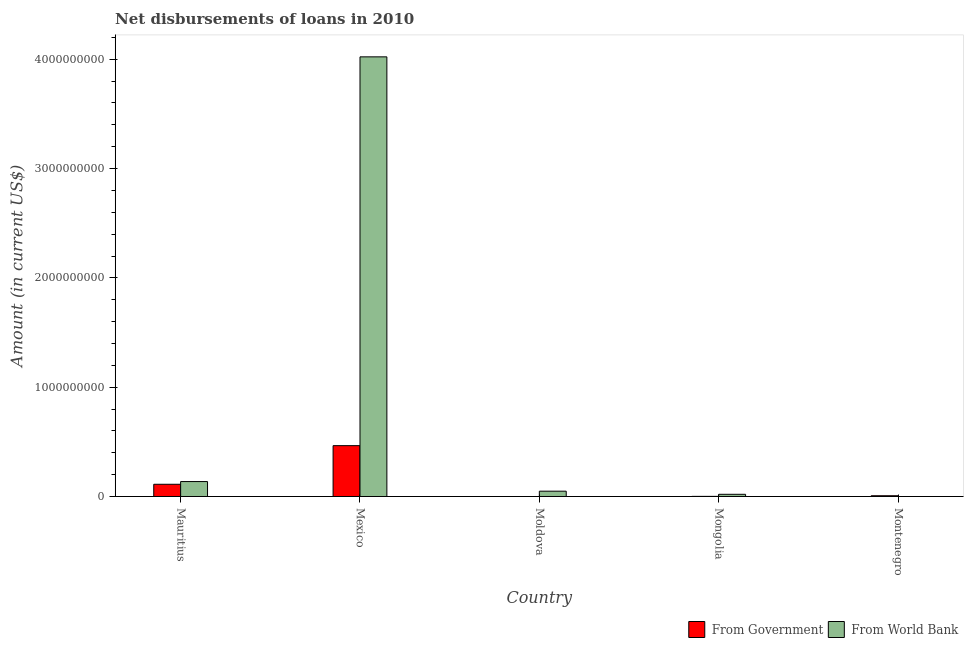Are the number of bars per tick equal to the number of legend labels?
Your answer should be compact. No. Are the number of bars on each tick of the X-axis equal?
Provide a succinct answer. No. How many bars are there on the 4th tick from the left?
Give a very brief answer. 2. How many bars are there on the 4th tick from the right?
Give a very brief answer. 2. What is the label of the 5th group of bars from the left?
Make the answer very short. Montenegro. In how many cases, is the number of bars for a given country not equal to the number of legend labels?
Your answer should be very brief. 2. What is the net disbursements of loan from world bank in Moldova?
Your answer should be compact. 4.88e+07. Across all countries, what is the maximum net disbursements of loan from world bank?
Your answer should be compact. 4.02e+09. Across all countries, what is the minimum net disbursements of loan from world bank?
Your response must be concise. 0. What is the total net disbursements of loan from world bank in the graph?
Your response must be concise. 4.23e+09. What is the difference between the net disbursements of loan from world bank in Mauritius and that in Moldova?
Provide a succinct answer. 8.80e+07. What is the average net disbursements of loan from world bank per country?
Make the answer very short. 8.46e+08. What is the difference between the net disbursements of loan from government and net disbursements of loan from world bank in Mongolia?
Offer a terse response. -1.88e+07. In how many countries, is the net disbursements of loan from government greater than 3800000000 US$?
Make the answer very short. 0. What is the ratio of the net disbursements of loan from government in Mongolia to that in Montenegro?
Provide a short and direct response. 0.19. Is the net disbursements of loan from government in Mauritius less than that in Montenegro?
Keep it short and to the point. No. What is the difference between the highest and the second highest net disbursements of loan from government?
Provide a succinct answer. 3.53e+08. What is the difference between the highest and the lowest net disbursements of loan from world bank?
Ensure brevity in your answer.  4.02e+09. How many countries are there in the graph?
Offer a terse response. 5. What is the difference between two consecutive major ticks on the Y-axis?
Make the answer very short. 1.00e+09. Does the graph contain grids?
Your response must be concise. No. Where does the legend appear in the graph?
Keep it short and to the point. Bottom right. How many legend labels are there?
Give a very brief answer. 2. What is the title of the graph?
Make the answer very short. Net disbursements of loans in 2010. What is the label or title of the Y-axis?
Keep it short and to the point. Amount (in current US$). What is the Amount (in current US$) of From Government in Mauritius?
Offer a terse response. 1.12e+08. What is the Amount (in current US$) of From World Bank in Mauritius?
Offer a terse response. 1.37e+08. What is the Amount (in current US$) of From Government in Mexico?
Give a very brief answer. 4.65e+08. What is the Amount (in current US$) in From World Bank in Mexico?
Offer a very short reply. 4.02e+09. What is the Amount (in current US$) in From Government in Moldova?
Provide a succinct answer. 0. What is the Amount (in current US$) of From World Bank in Moldova?
Provide a succinct answer. 4.88e+07. What is the Amount (in current US$) of From Government in Mongolia?
Your response must be concise. 1.30e+06. What is the Amount (in current US$) of From World Bank in Mongolia?
Make the answer very short. 2.01e+07. What is the Amount (in current US$) of From Government in Montenegro?
Give a very brief answer. 7.04e+06. Across all countries, what is the maximum Amount (in current US$) of From Government?
Give a very brief answer. 4.65e+08. Across all countries, what is the maximum Amount (in current US$) of From World Bank?
Provide a short and direct response. 4.02e+09. Across all countries, what is the minimum Amount (in current US$) of From Government?
Keep it short and to the point. 0. Across all countries, what is the minimum Amount (in current US$) of From World Bank?
Your answer should be compact. 0. What is the total Amount (in current US$) of From Government in the graph?
Your answer should be very brief. 5.86e+08. What is the total Amount (in current US$) in From World Bank in the graph?
Make the answer very short. 4.23e+09. What is the difference between the Amount (in current US$) of From Government in Mauritius and that in Mexico?
Ensure brevity in your answer.  -3.53e+08. What is the difference between the Amount (in current US$) of From World Bank in Mauritius and that in Mexico?
Provide a succinct answer. -3.89e+09. What is the difference between the Amount (in current US$) of From World Bank in Mauritius and that in Moldova?
Make the answer very short. 8.80e+07. What is the difference between the Amount (in current US$) of From Government in Mauritius and that in Mongolia?
Ensure brevity in your answer.  1.11e+08. What is the difference between the Amount (in current US$) in From World Bank in Mauritius and that in Mongolia?
Ensure brevity in your answer.  1.17e+08. What is the difference between the Amount (in current US$) of From Government in Mauritius and that in Montenegro?
Ensure brevity in your answer.  1.05e+08. What is the difference between the Amount (in current US$) in From World Bank in Mexico and that in Moldova?
Make the answer very short. 3.97e+09. What is the difference between the Amount (in current US$) in From Government in Mexico and that in Mongolia?
Your response must be concise. 4.64e+08. What is the difference between the Amount (in current US$) in From World Bank in Mexico and that in Mongolia?
Give a very brief answer. 4.00e+09. What is the difference between the Amount (in current US$) of From Government in Mexico and that in Montenegro?
Ensure brevity in your answer.  4.58e+08. What is the difference between the Amount (in current US$) of From World Bank in Moldova and that in Mongolia?
Provide a succinct answer. 2.86e+07. What is the difference between the Amount (in current US$) in From Government in Mongolia and that in Montenegro?
Offer a very short reply. -5.73e+06. What is the difference between the Amount (in current US$) of From Government in Mauritius and the Amount (in current US$) of From World Bank in Mexico?
Your answer should be very brief. -3.91e+09. What is the difference between the Amount (in current US$) in From Government in Mauritius and the Amount (in current US$) in From World Bank in Moldova?
Your answer should be compact. 6.32e+07. What is the difference between the Amount (in current US$) in From Government in Mauritius and the Amount (in current US$) in From World Bank in Mongolia?
Provide a short and direct response. 9.18e+07. What is the difference between the Amount (in current US$) of From Government in Mexico and the Amount (in current US$) of From World Bank in Moldova?
Keep it short and to the point. 4.16e+08. What is the difference between the Amount (in current US$) in From Government in Mexico and the Amount (in current US$) in From World Bank in Mongolia?
Your answer should be compact. 4.45e+08. What is the average Amount (in current US$) in From Government per country?
Offer a very short reply. 1.17e+08. What is the average Amount (in current US$) in From World Bank per country?
Offer a terse response. 8.46e+08. What is the difference between the Amount (in current US$) in From Government and Amount (in current US$) in From World Bank in Mauritius?
Keep it short and to the point. -2.48e+07. What is the difference between the Amount (in current US$) of From Government and Amount (in current US$) of From World Bank in Mexico?
Offer a terse response. -3.56e+09. What is the difference between the Amount (in current US$) of From Government and Amount (in current US$) of From World Bank in Mongolia?
Offer a very short reply. -1.88e+07. What is the ratio of the Amount (in current US$) of From Government in Mauritius to that in Mexico?
Provide a succinct answer. 0.24. What is the ratio of the Amount (in current US$) of From World Bank in Mauritius to that in Mexico?
Ensure brevity in your answer.  0.03. What is the ratio of the Amount (in current US$) of From World Bank in Mauritius to that in Moldova?
Offer a terse response. 2.8. What is the ratio of the Amount (in current US$) in From Government in Mauritius to that in Mongolia?
Your answer should be compact. 85.8. What is the ratio of the Amount (in current US$) of From World Bank in Mauritius to that in Mongolia?
Offer a terse response. 6.8. What is the ratio of the Amount (in current US$) in From Government in Mauritius to that in Montenegro?
Give a very brief answer. 15.91. What is the ratio of the Amount (in current US$) in From World Bank in Mexico to that in Moldova?
Your answer should be very brief. 82.47. What is the ratio of the Amount (in current US$) in From Government in Mexico to that in Mongolia?
Provide a succinct answer. 356.48. What is the ratio of the Amount (in current US$) of From World Bank in Mexico to that in Mongolia?
Keep it short and to the point. 199.82. What is the ratio of the Amount (in current US$) of From Government in Mexico to that in Montenegro?
Give a very brief answer. 66.11. What is the ratio of the Amount (in current US$) in From World Bank in Moldova to that in Mongolia?
Offer a terse response. 2.42. What is the ratio of the Amount (in current US$) of From Government in Mongolia to that in Montenegro?
Your answer should be very brief. 0.19. What is the difference between the highest and the second highest Amount (in current US$) in From Government?
Your response must be concise. 3.53e+08. What is the difference between the highest and the second highest Amount (in current US$) of From World Bank?
Ensure brevity in your answer.  3.89e+09. What is the difference between the highest and the lowest Amount (in current US$) in From Government?
Keep it short and to the point. 4.65e+08. What is the difference between the highest and the lowest Amount (in current US$) of From World Bank?
Offer a terse response. 4.02e+09. 